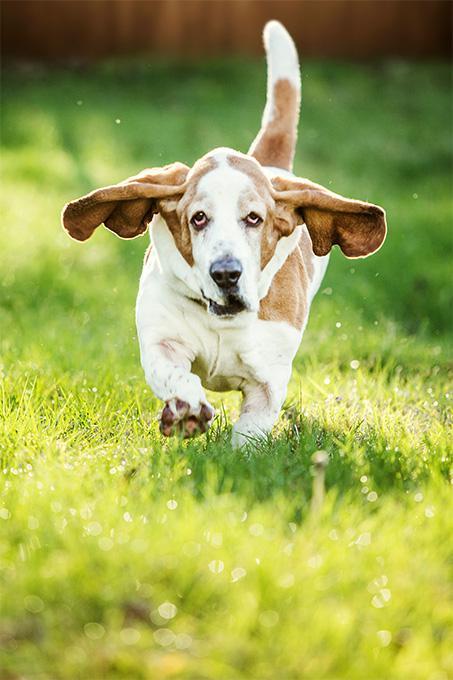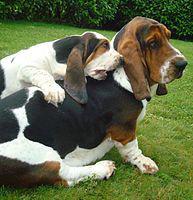The first image is the image on the left, the second image is the image on the right. For the images displayed, is the sentence "One image shows a dog's body in profile, turned toward the left." factually correct? Answer yes or no. No. The first image is the image on the left, the second image is the image on the right. Considering the images on both sides, is "One of the dogs is running in the grass." valid? Answer yes or no. Yes. 